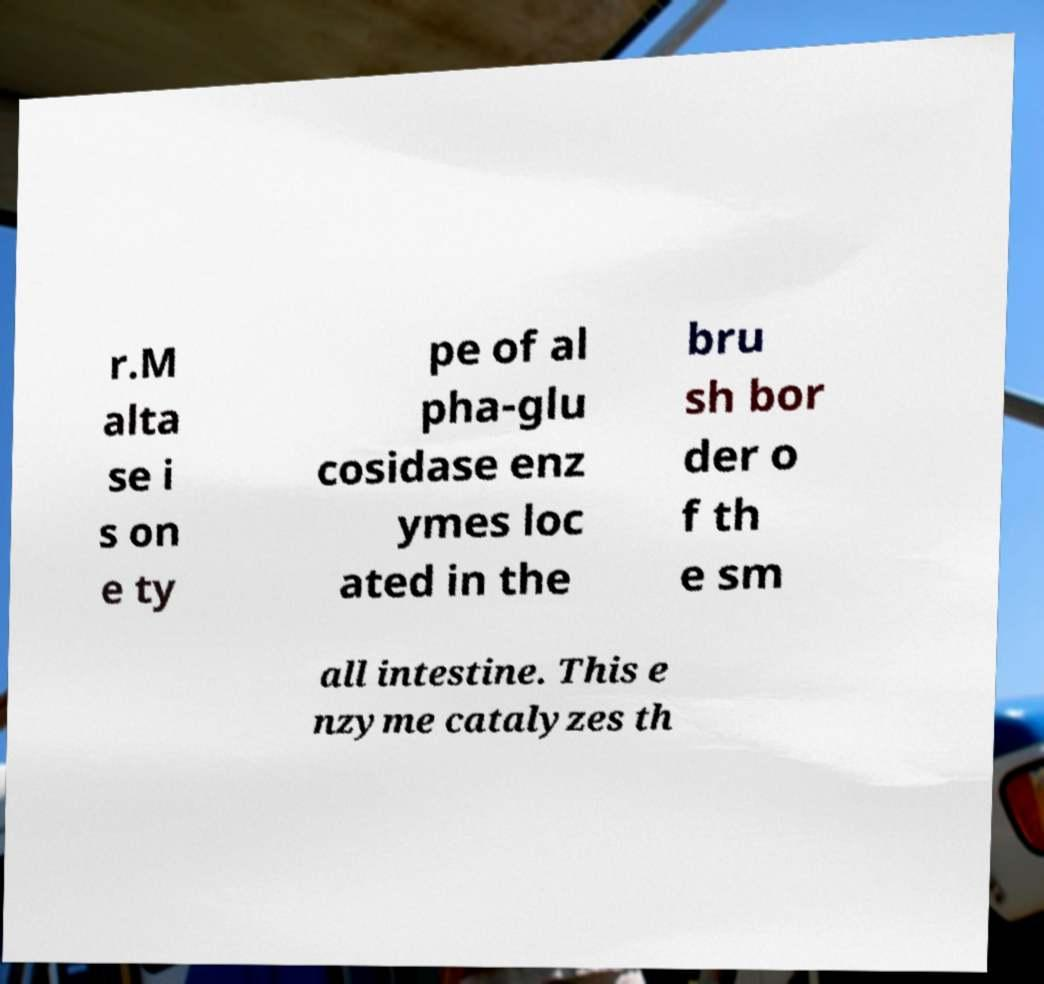What messages or text are displayed in this image? I need them in a readable, typed format. r.M alta se i s on e ty pe of al pha-glu cosidase enz ymes loc ated in the bru sh bor der o f th e sm all intestine. This e nzyme catalyzes th 